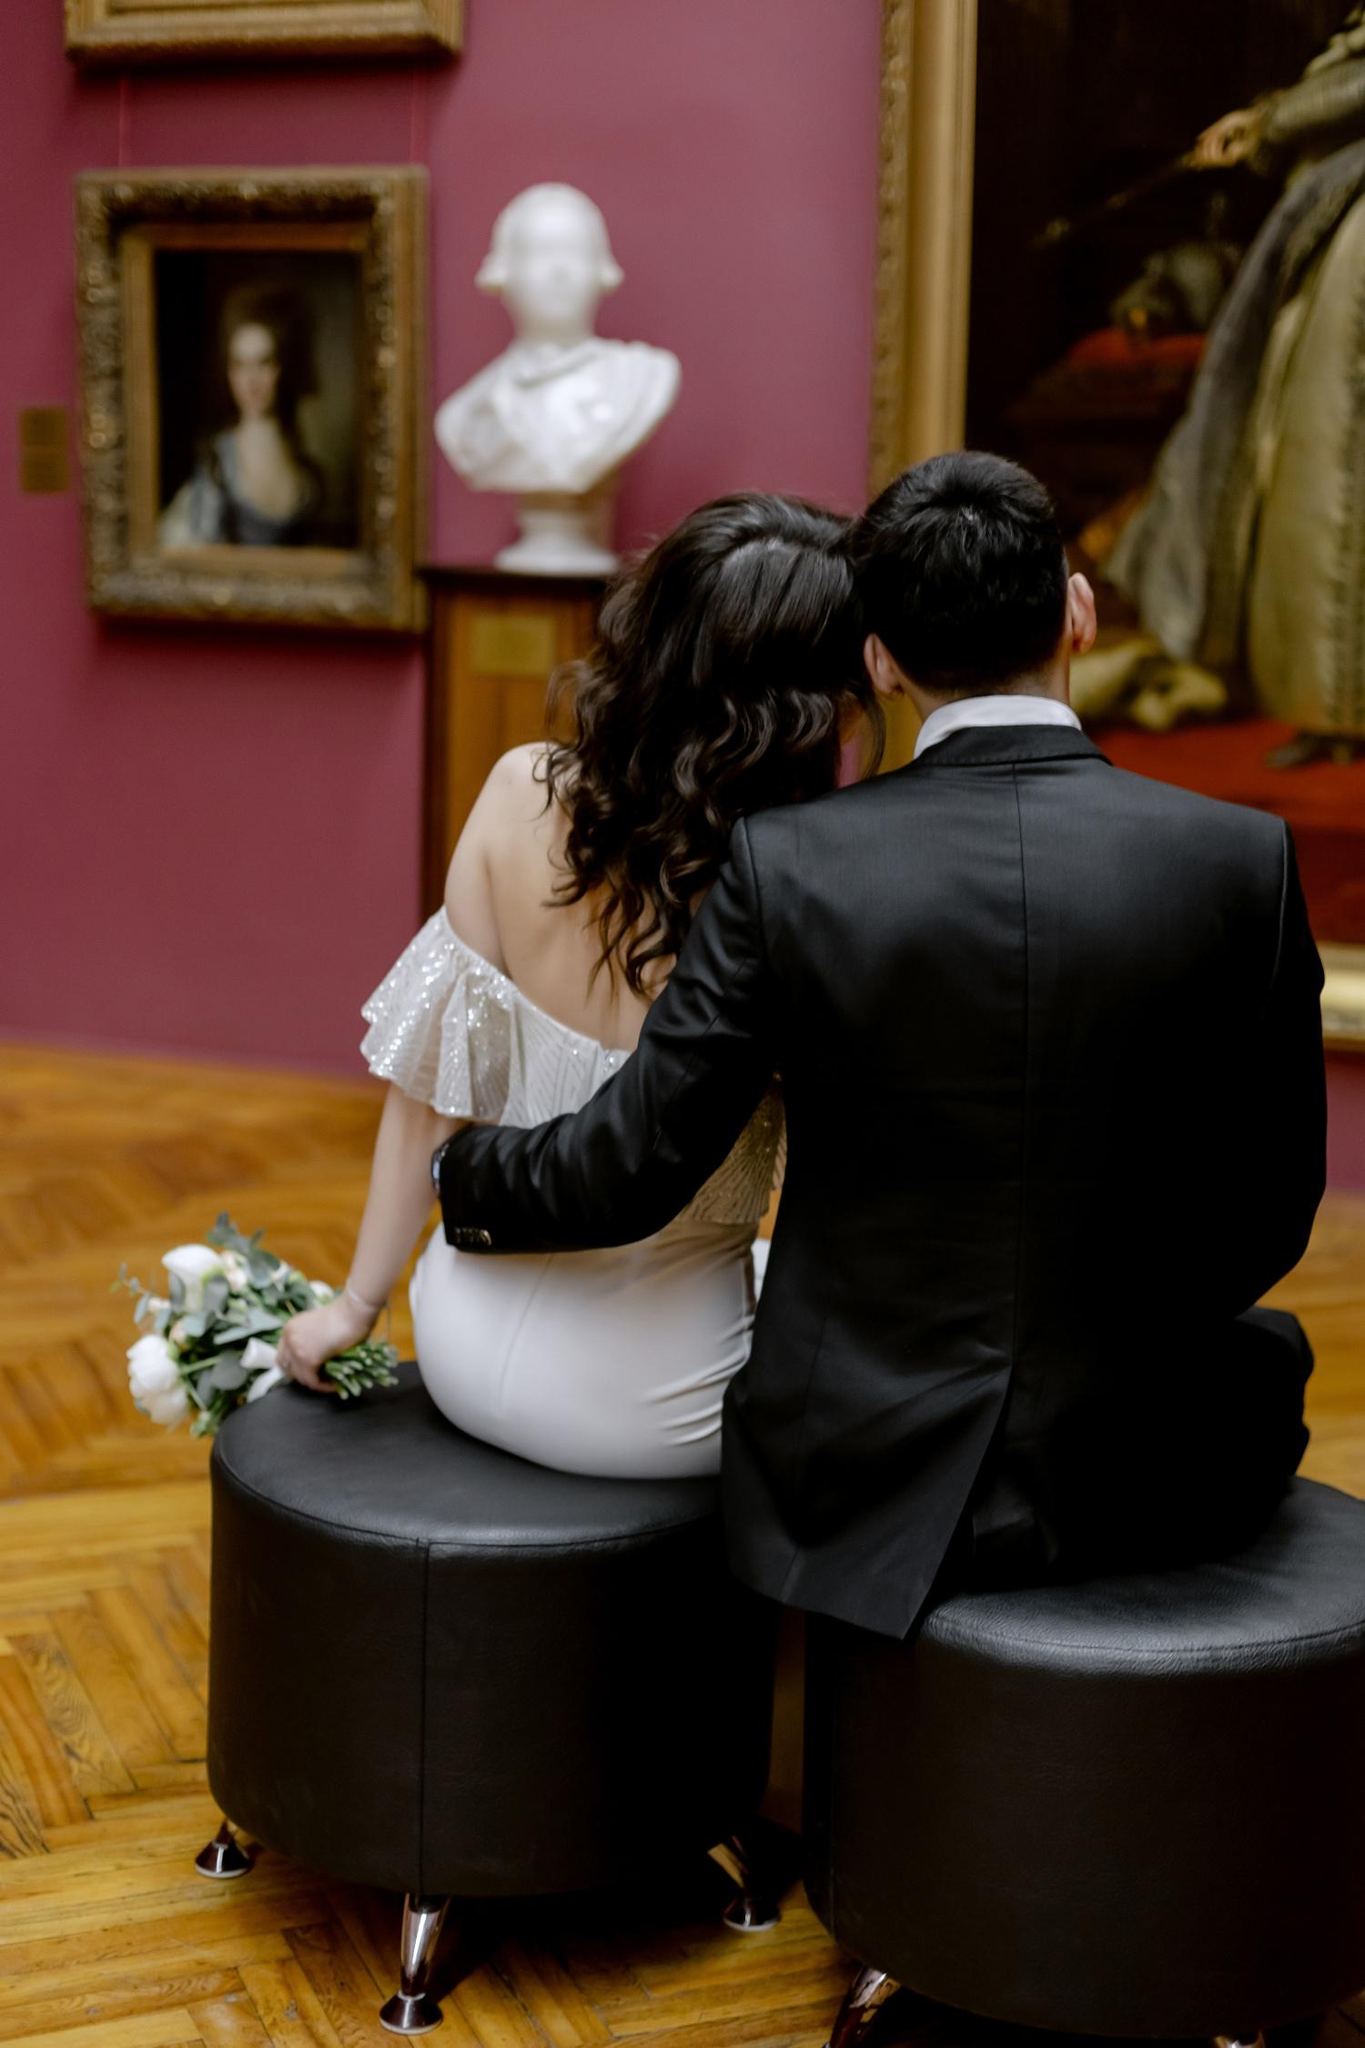What's happening in the scene?
 The image captures a couple, engrossed in the art of a gallery. They are seated on a round black ottoman, their backs to the camera, creating an air of intimacy. The woman, clad in a white dress, holds a bouquet of white flowers, while the man complements her in a black suit. Their attention is drawn to a white bust sculpture and a painting of a woman in a gold frame, the subjects of which add a touch of antiquity to the scene. The red walls of the gallery imbue the space with warmth, while the wooden flooring adds a rustic charm. The image is a blend of modernity and tradition, a snapshot of a moment shared between two individuals amidst the timeless beauty of art.

As for the landmark information "sa_1211", it appears to be associated with Landmark Management Switzerland S.A., located at 6, place des Eaux-Vives, PO Box 1211, Geneva 3, Switzerland[^1^]. However, without a direct visual reference in the image, it's challenging to confirm this connection. The image does not provide any explicit details that could be linked to this landmark. The art gallery setting doesn't offer any identifiable features or symbols that could be associated with a specific worldwide landmark. Therefore, the connection between the image and the landmark information "sa_1211" remains speculative based on the available data. 